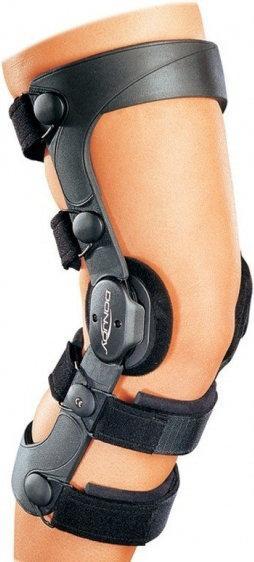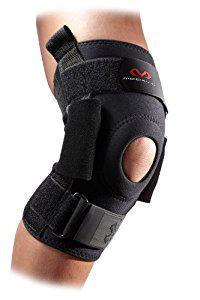The first image is the image on the left, the second image is the image on the right. For the images displayed, is the sentence "One of the knee braces has a small hole at the knee cap in an otherwise solid brace." factually correct? Answer yes or no. Yes. 